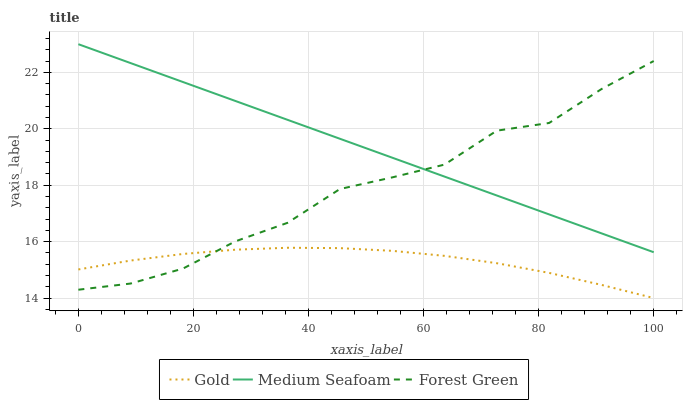Does Gold have the minimum area under the curve?
Answer yes or no. Yes. Does Medium Seafoam have the maximum area under the curve?
Answer yes or no. Yes. Does Medium Seafoam have the minimum area under the curve?
Answer yes or no. No. Does Gold have the maximum area under the curve?
Answer yes or no. No. Is Medium Seafoam the smoothest?
Answer yes or no. Yes. Is Forest Green the roughest?
Answer yes or no. Yes. Is Gold the smoothest?
Answer yes or no. No. Is Gold the roughest?
Answer yes or no. No. Does Medium Seafoam have the lowest value?
Answer yes or no. No. Does Medium Seafoam have the highest value?
Answer yes or no. Yes. Does Gold have the highest value?
Answer yes or no. No. Is Gold less than Medium Seafoam?
Answer yes or no. Yes. Is Medium Seafoam greater than Gold?
Answer yes or no. Yes. Does Forest Green intersect Medium Seafoam?
Answer yes or no. Yes. Is Forest Green less than Medium Seafoam?
Answer yes or no. No. Is Forest Green greater than Medium Seafoam?
Answer yes or no. No. Does Gold intersect Medium Seafoam?
Answer yes or no. No. 